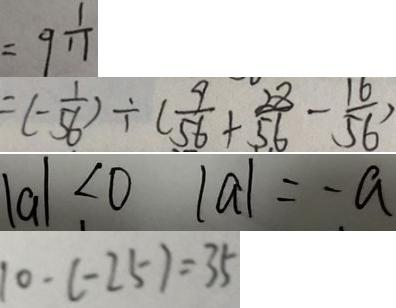<formula> <loc_0><loc_0><loc_500><loc_500>= 9 \frac { 1 } { 1 1 } 
 = ( - \frac { 1 } { 5 6 } ) \div ( \frac { 9 } { 5 6 } + \frac { 2 8 } { 5 6 } - \frac { 1 6 } { 5 6 } ) 
 \vert a \vert < 0 \vert a \vert = - a 
 1 0 - ( - 2 5 ) = 3 5</formula> 